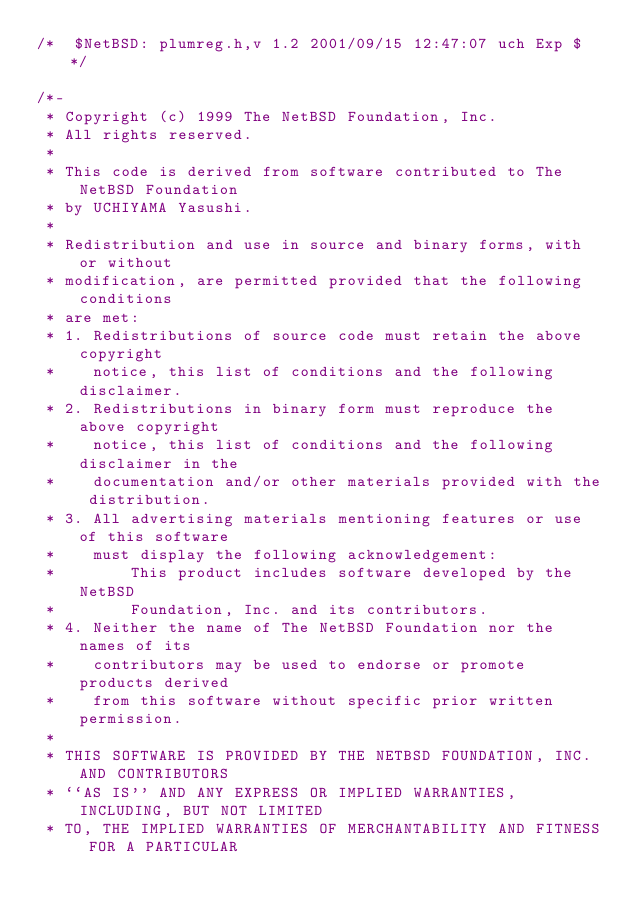Convert code to text. <code><loc_0><loc_0><loc_500><loc_500><_C_>/*	$NetBSD: plumreg.h,v 1.2 2001/09/15 12:47:07 uch Exp $ */

/*-
 * Copyright (c) 1999 The NetBSD Foundation, Inc.
 * All rights reserved.
 *
 * This code is derived from software contributed to The NetBSD Foundation
 * by UCHIYAMA Yasushi.
 *
 * Redistribution and use in source and binary forms, with or without
 * modification, are permitted provided that the following conditions
 * are met:
 * 1. Redistributions of source code must retain the above copyright
 *    notice, this list of conditions and the following disclaimer.
 * 2. Redistributions in binary form must reproduce the above copyright
 *    notice, this list of conditions and the following disclaimer in the
 *    documentation and/or other materials provided with the distribution.
 * 3. All advertising materials mentioning features or use of this software
 *    must display the following acknowledgement:
 *        This product includes software developed by the NetBSD
 *        Foundation, Inc. and its contributors.
 * 4. Neither the name of The NetBSD Foundation nor the names of its
 *    contributors may be used to endorse or promote products derived
 *    from this software without specific prior written permission.
 *
 * THIS SOFTWARE IS PROVIDED BY THE NETBSD FOUNDATION, INC. AND CONTRIBUTORS
 * ``AS IS'' AND ANY EXPRESS OR IMPLIED WARRANTIES, INCLUDING, BUT NOT LIMITED
 * TO, THE IMPLIED WARRANTIES OF MERCHANTABILITY AND FITNESS FOR A PARTICULAR</code> 